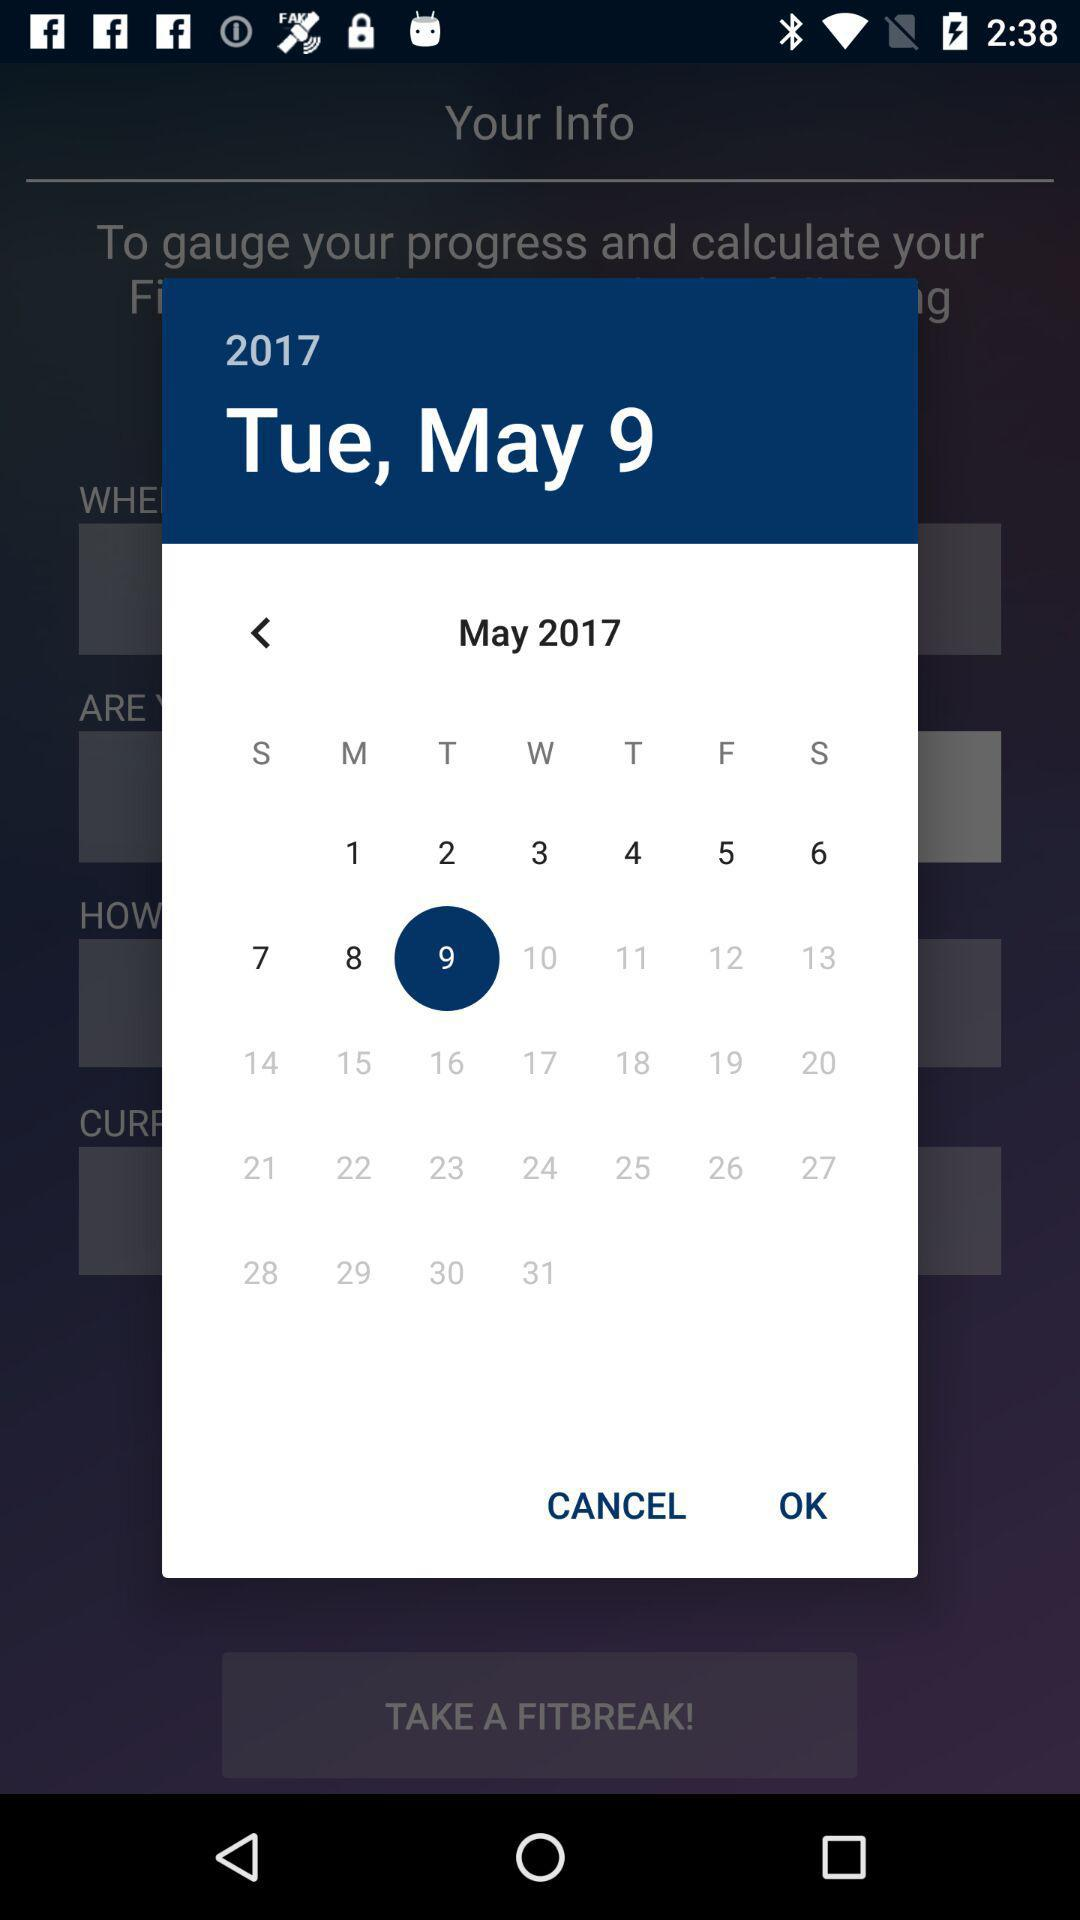What date is selected? The selected date is Tuesday, May 9, 2017. 